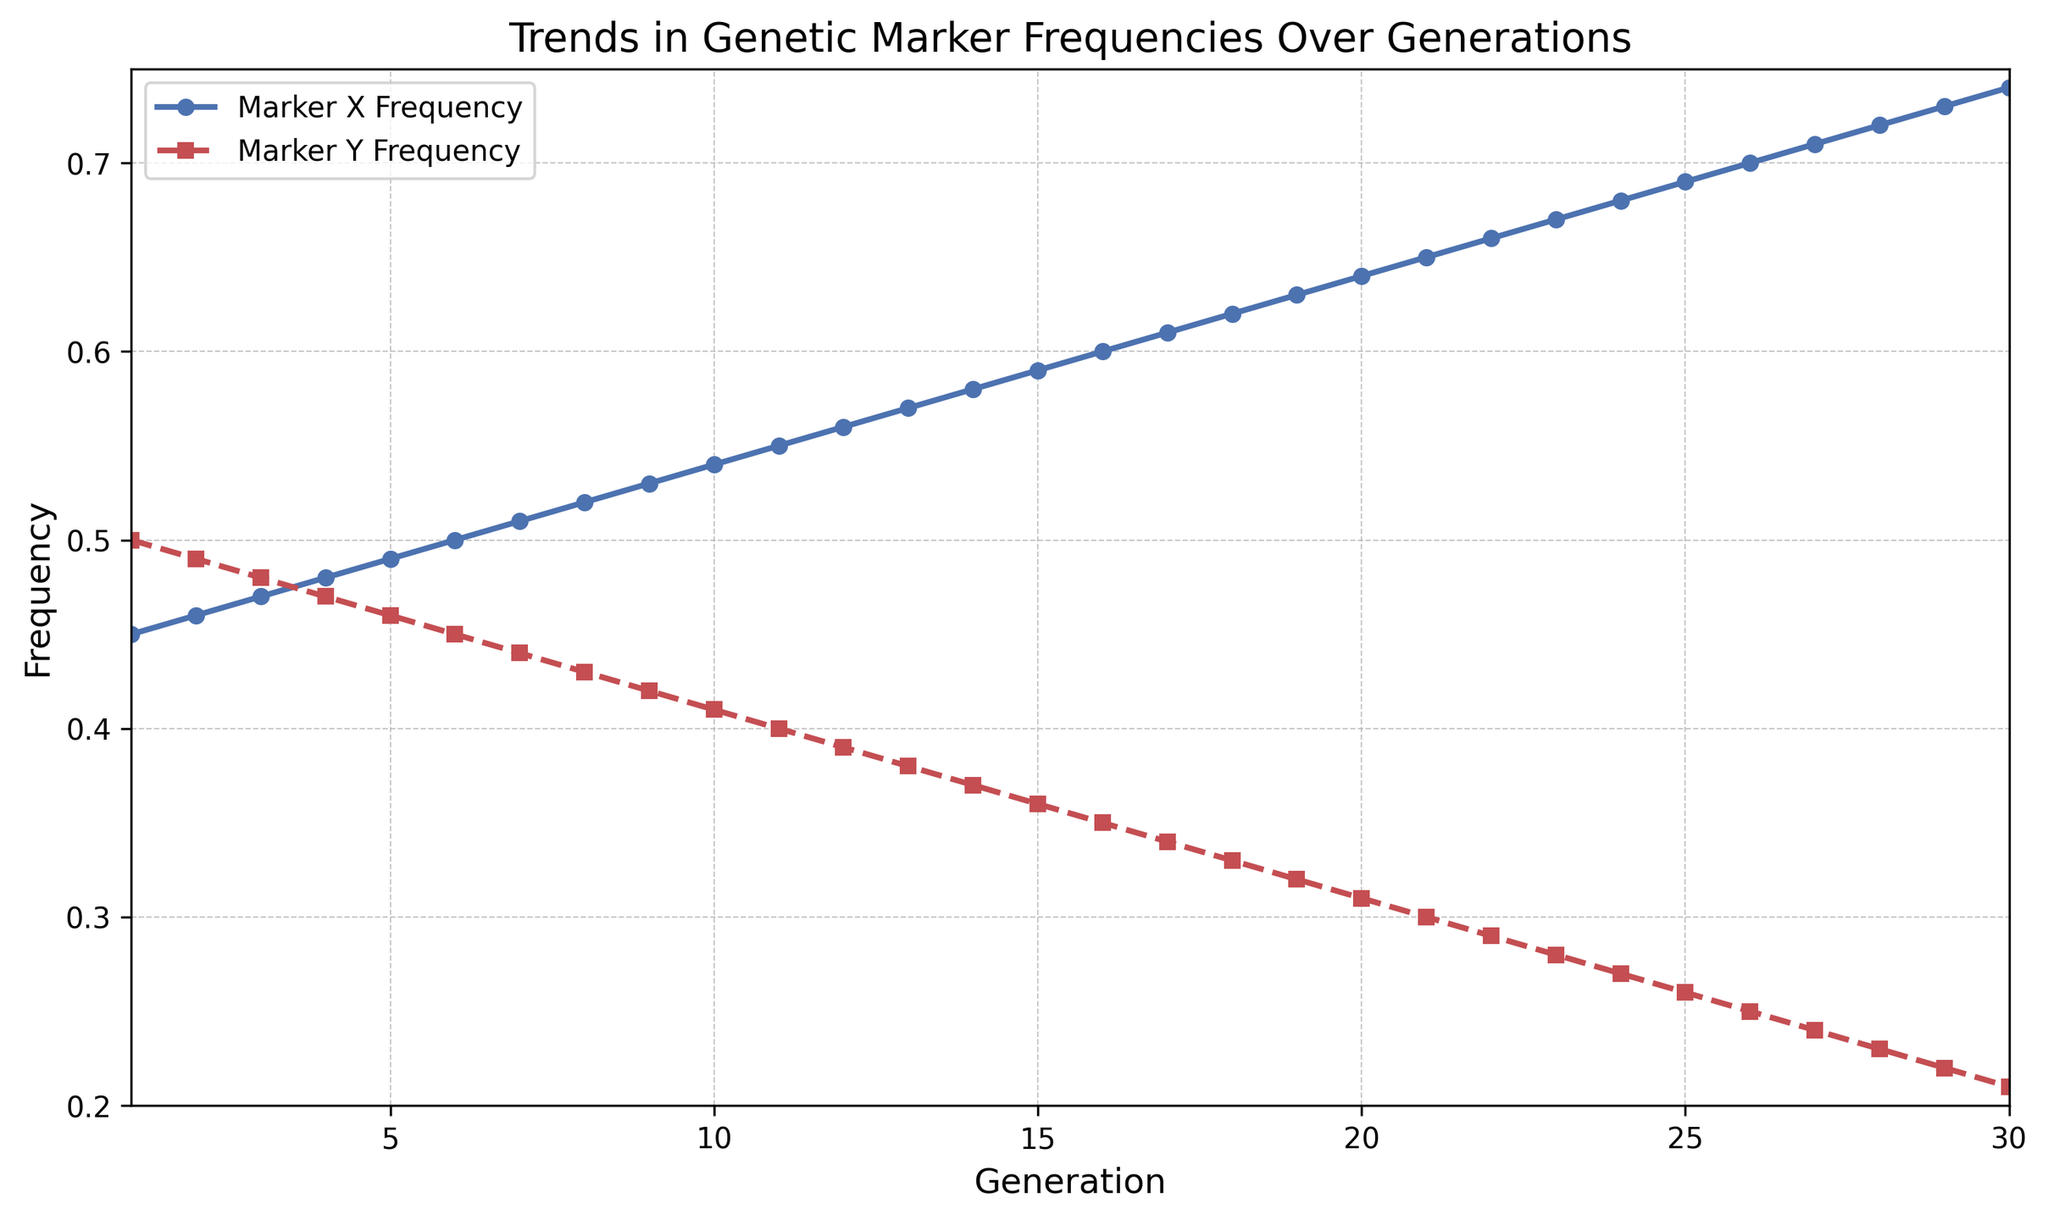What is the trend in the frequencies of Marker X and Marker Y over the generations? Marker X frequency increases steadily from 0.45 to 0.74 over 30 generations, whereas Marker Y frequency decreases steadily from 0.50 to 0.21 over the same period.
Answer: Marker X increases, Marker Y decreases What is the frequency of Marker X at Generation 15? At Generation 15, the line representing Marker X Frequency reaches a value on the y-axis, which is 0.59.
Answer: 0.59 Which marker shows a higher frequency at Generation 10? By looking at Generation 10 on the x-axis, Marker X frequency is 0.54, while Marker Y frequency is 0.41. Marker X thus has a higher frequency.
Answer: Marker X How much did the frequency of Marker Y decrease from Generation 1 to Generation 30? The frequency of Marker Y at Generation 1 is 0.50, and at Generation 30, it is 0.21. The decrease is 0.50 - 0.21 = 0.29.
Answer: 0.29 What is the difference in frequency between Marker X and Marker Y at Generation 20? At Generation 20, Marker X frequency is 0.64 and Marker Y frequency is 0.31. The difference is 0.64 - 0.31 = 0.33.
Answer: 0.33 At which generations do the frequencies of Marker X and Marker Y become equal? By examining the lines, they seem to be closest at Generation 6, where both frequencies are around 0.50 and 0.45. Specifically, they cross at Generation 5 when both are equal.
Answer: Generation 5 Which marker's frequency shows a larger overall change from start to end? Marker X changes from 0.45 to 0.74 (an increase of 0.29), while Marker Y changes from 0.50 to 0.21 (a decrease of 0.29). The magnitude of change is equal for both markers.
Answer: Both have the same magnitude (0.29) What is the average frequency of Marker X over the 30 generations? Sum of frequencies from Marker X is calculated, and then divided by 30 (total generations): (0.45 + 0.46 + ... + 0.74)/30 = 18/30 = 0.60
Answer: 0.60 